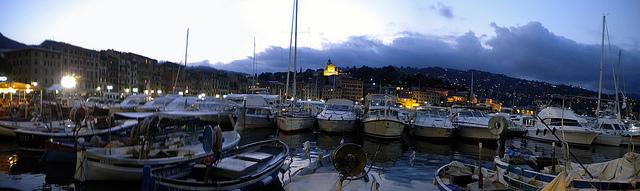How many red trucks are in the first row?
Short answer required. 0. Is it cloudy?
Answer briefly. Yes. Are there more than seven boats?
Concise answer only. Yes. 